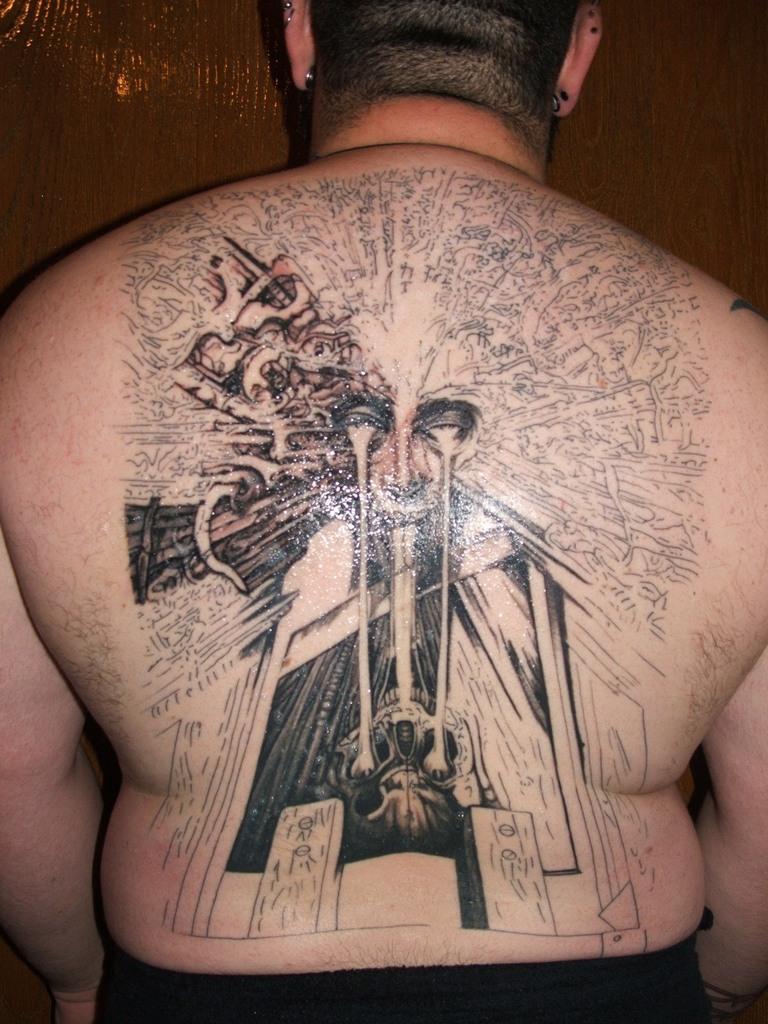Can you describe this image briefly? On this person's body there is a tattoo. Background we can see wooden wall.  